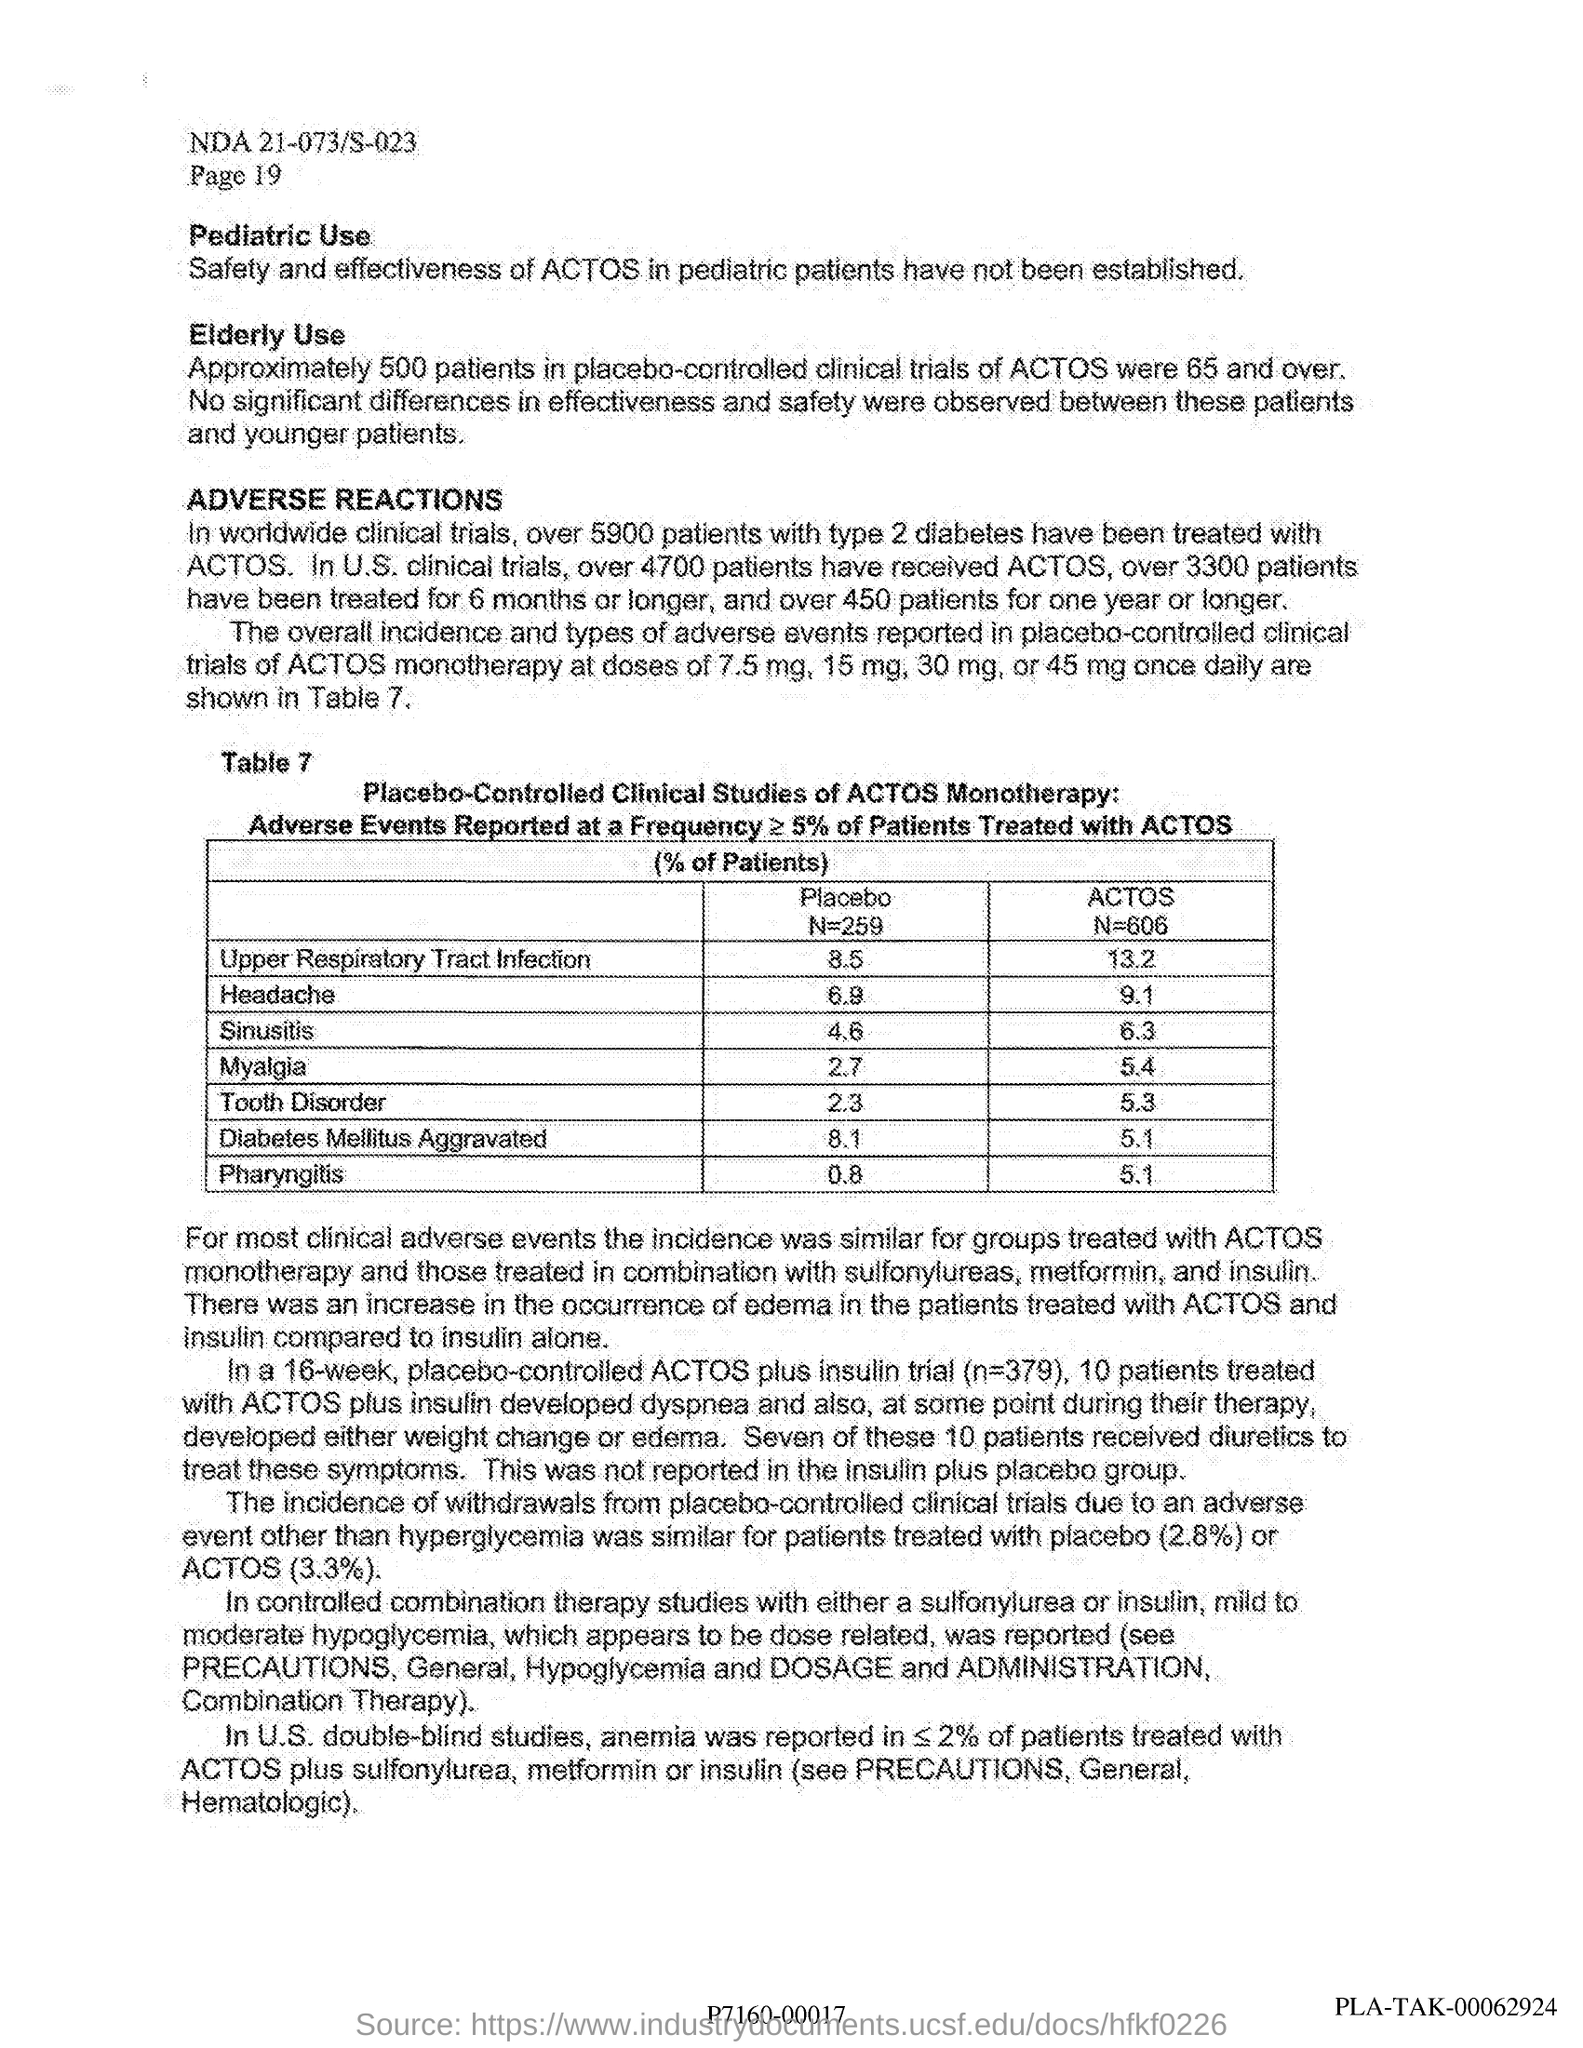In U.S. clinical trials, how many patients have received ACTOS?
Your answer should be compact. OVER 4700. Which medicine is used for treating type 2 diabetes in over 5900 patients?
Your response must be concise. ACTOS. 